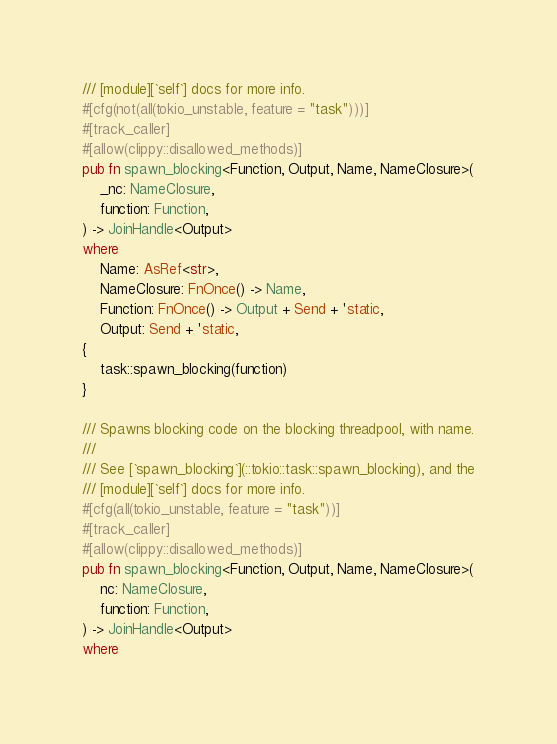<code> <loc_0><loc_0><loc_500><loc_500><_Rust_>/// [module][`self`] docs for more info.
#[cfg(not(all(tokio_unstable, feature = "task")))]
#[track_caller]
#[allow(clippy::disallowed_methods)]
pub fn spawn_blocking<Function, Output, Name, NameClosure>(
    _nc: NameClosure,
    function: Function,
) -> JoinHandle<Output>
where
    Name: AsRef<str>,
    NameClosure: FnOnce() -> Name,
    Function: FnOnce() -> Output + Send + 'static,
    Output: Send + 'static,
{
    task::spawn_blocking(function)
}

/// Spawns blocking code on the blocking threadpool, with name.
///
/// See [`spawn_blocking`](::tokio::task::spawn_blocking), and the
/// [module][`self`] docs for more info.
#[cfg(all(tokio_unstable, feature = "task"))]
#[track_caller]
#[allow(clippy::disallowed_methods)]
pub fn spawn_blocking<Function, Output, Name, NameClosure>(
    nc: NameClosure,
    function: Function,
) -> JoinHandle<Output>
where</code> 